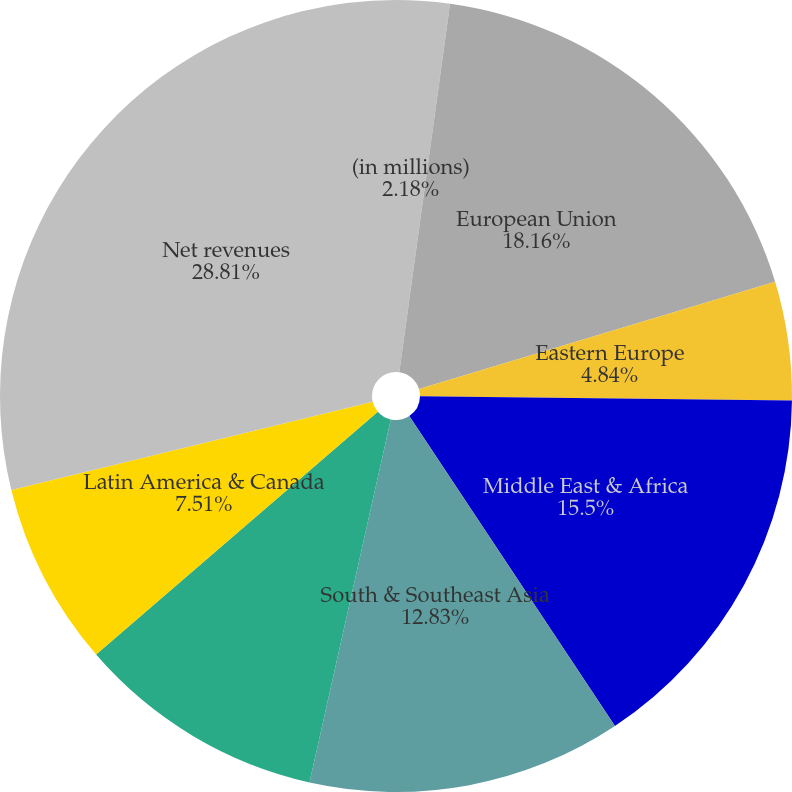Convert chart to OTSL. <chart><loc_0><loc_0><loc_500><loc_500><pie_chart><fcel>(in millions)<fcel>European Union<fcel>Eastern Europe<fcel>Middle East & Africa<fcel>South & Southeast Asia<fcel>East Asia & Australia<fcel>Latin America & Canada<fcel>Net revenues<nl><fcel>2.18%<fcel>18.16%<fcel>4.84%<fcel>15.5%<fcel>12.83%<fcel>10.17%<fcel>7.51%<fcel>28.82%<nl></chart> 